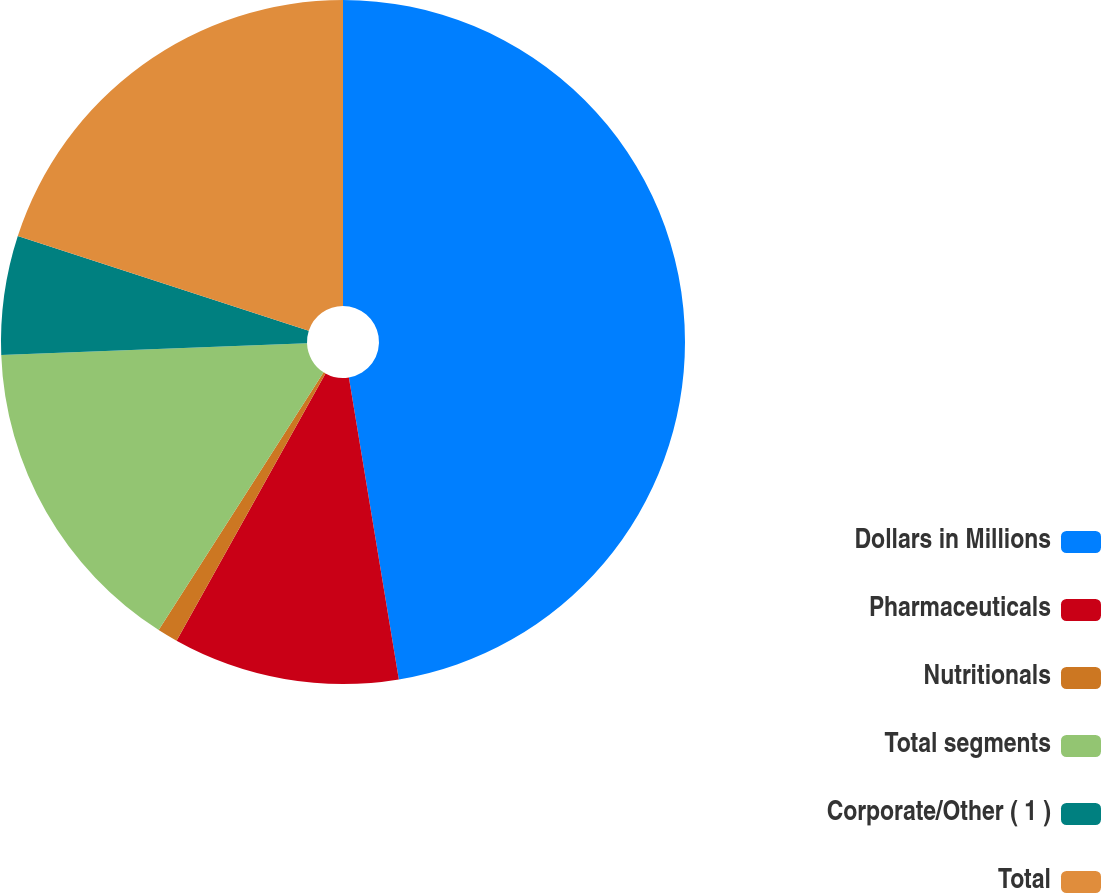Convert chart. <chart><loc_0><loc_0><loc_500><loc_500><pie_chart><fcel>Dollars in Millions<fcel>Pharmaceuticals<fcel>Nutritionals<fcel>Total segments<fcel>Corporate/Other ( 1 )<fcel>Total<nl><fcel>47.39%<fcel>10.7%<fcel>0.97%<fcel>15.34%<fcel>5.61%<fcel>19.99%<nl></chart> 